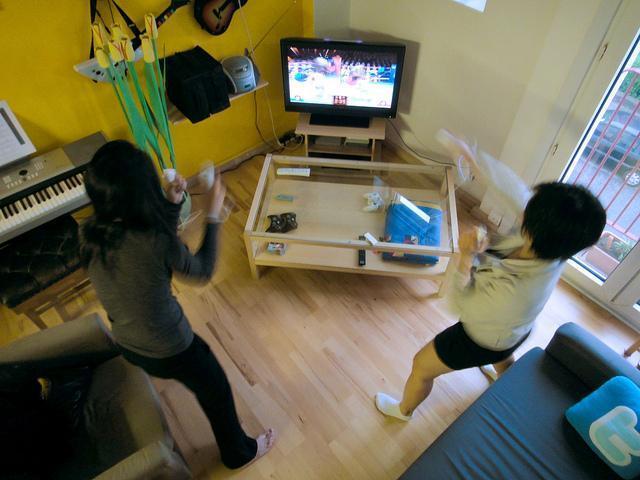How many couches are in the photo?
Give a very brief answer. 2. How many people are there?
Give a very brief answer. 2. How many chairs are there?
Give a very brief answer. 2. 